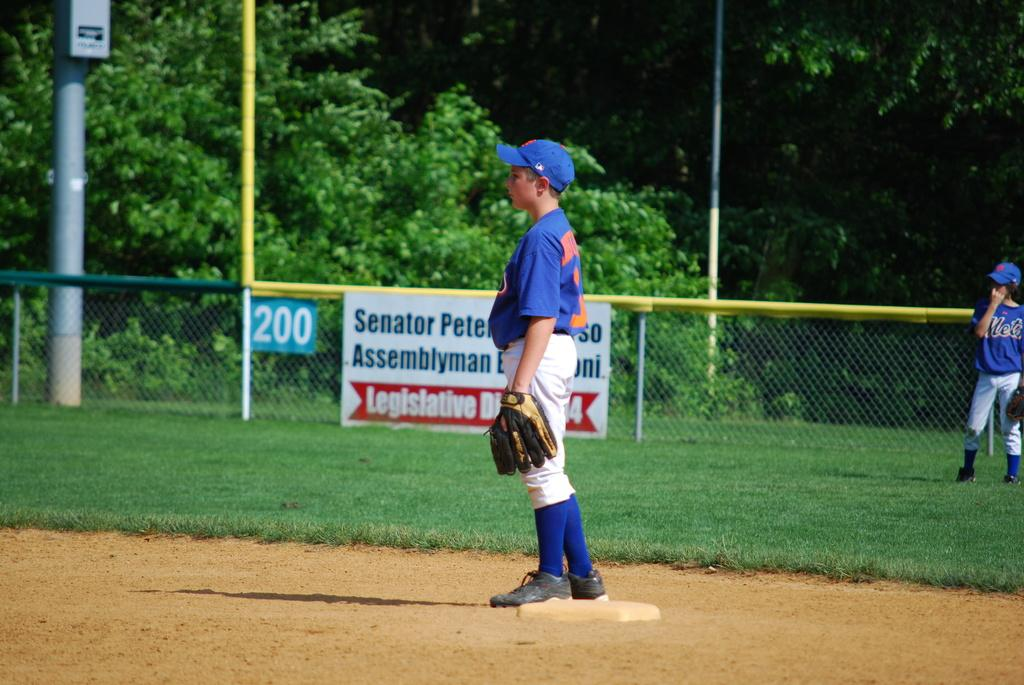<image>
Give a short and clear explanation of the subsequent image. Boys on a baseball field in uniform standing near a Senator advertisement banner. 